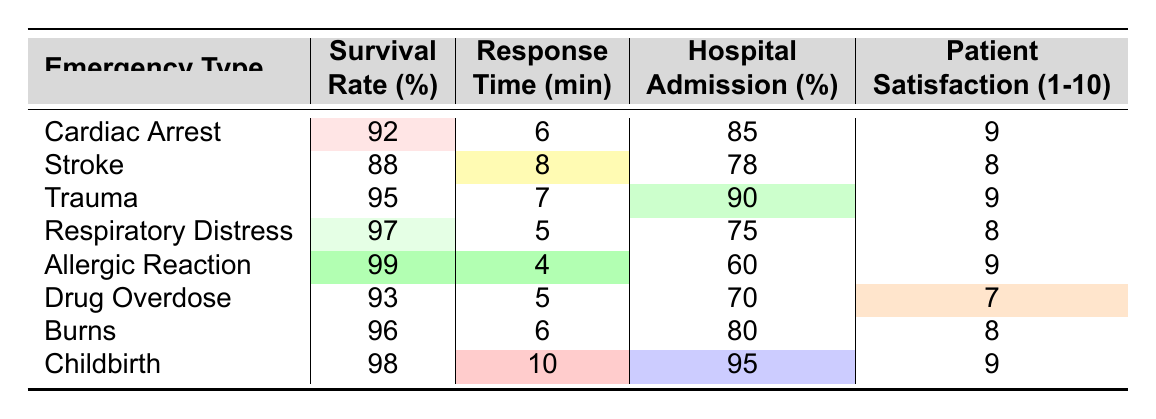What is the survival rate for patients experiencing a stroke? Looking at the "Stroke" row in the table, the survival rate is listed as 88%.
Answer: 88% What is the response time (in minutes) for respiratory distress cases? The table shows that the response time for respiratory distress is 5 minutes.
Answer: 5 Which emergency type has the highest hospital admission rate? By examining the "Hospital Admission (%)" column, we see that "Childbirth" has the highest admission rate at 95%.
Answer: 95% What is the average patient satisfaction score across all emergency types? Adding the satisfaction scores together: (9 + 8 + 9 + 8 + 9 + 7 + 8 + 9) = 67. There are 8 types, so the average is 67/8 = 8.375.
Answer: 8.375 Is the survival rate for drug overdose patients greater than that for allergic reactions? The survival rate for drug overdose is 93% and for allergic reactions it is 99%. Since 93 is less than 99, the statement is false.
Answer: No How does the response time for cardiac arrest compare to that for drug overdose cases? The response time for cardiac arrest is 6 minutes, while for drug overdose it's 5 minutes. Since 6 is greater than 5, cardiac arrest has a longer response time.
Answer: Cardiac arrest has a longer response time What is the difference in survival rates between trauma cases and respiratory distress cases? The survival rate for trauma is 95% and for respiratory distress, it's 97%. The difference is 97 - 95 = 2%.
Answer: 2% Which emergency type has the lowest satisfaction score and what is that score? The lowest satisfaction score is for drug overdose cases, which is 7.
Answer: 7 If the response time for childbirth were to decrease by 3 minutes, what would it be? Currently, the response time for childbirth is 10 minutes. If we decrease it by 3 minutes, the new response time would be 10 - 3 = 7 minutes.
Answer: 7 Which emergency type has the lowest survival rate? The survival rate for stroke is 88%, which is the lowest among the emergency types listed.
Answer: 88% 